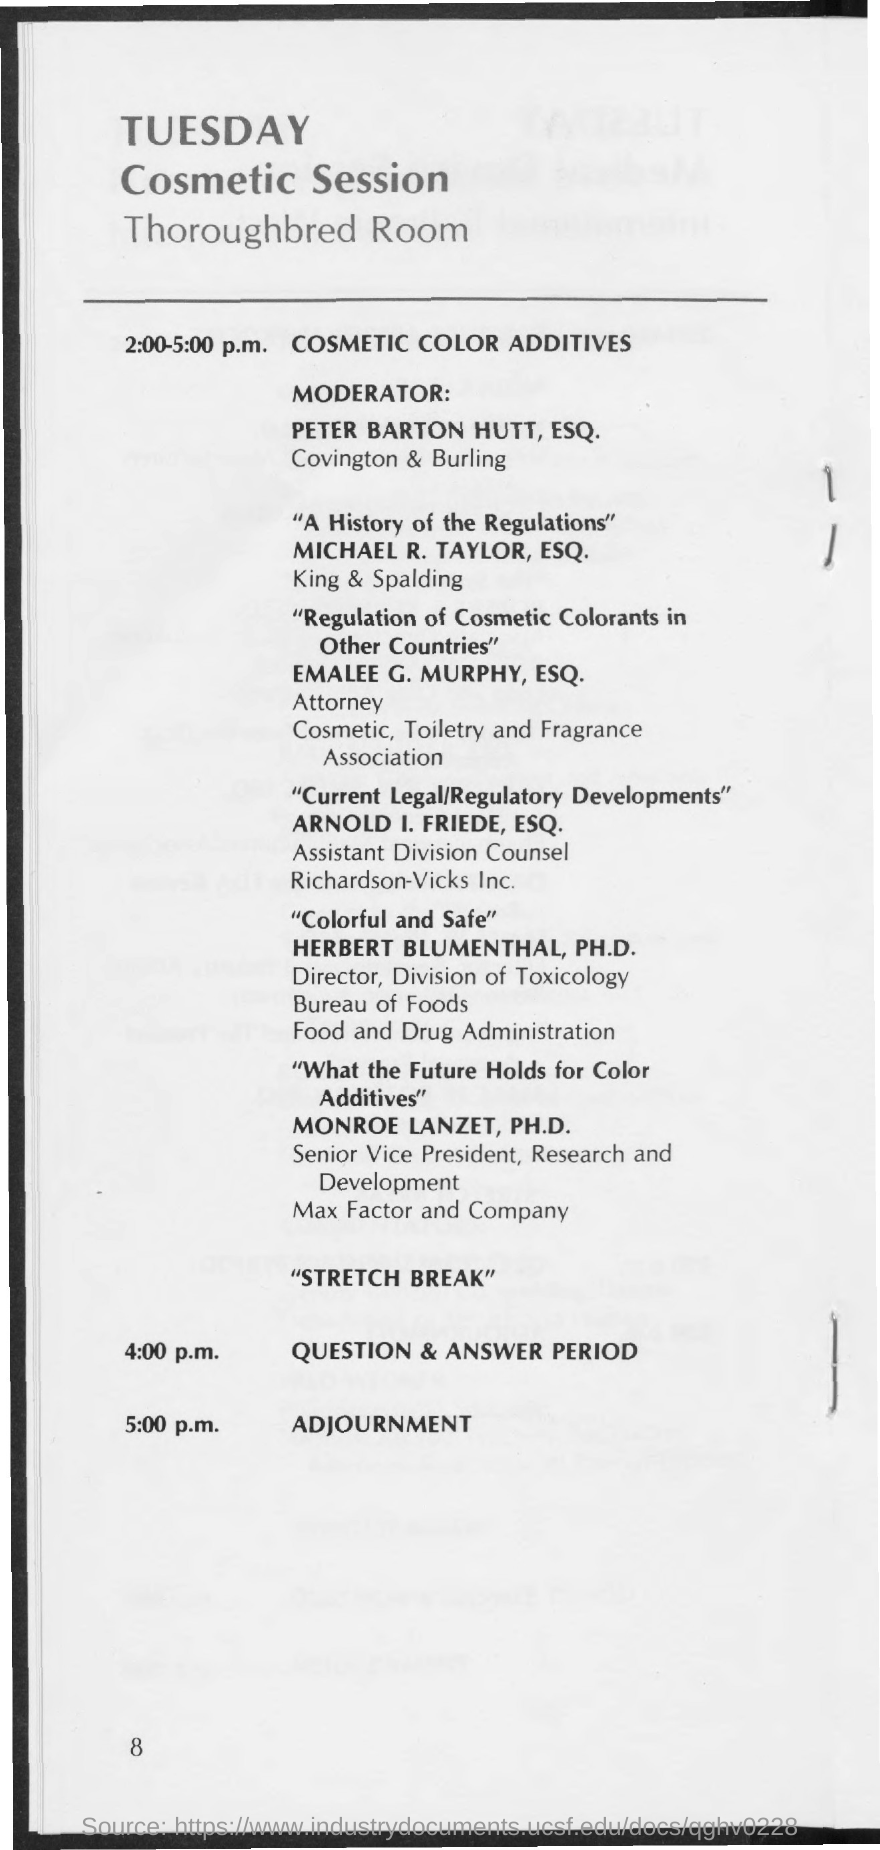Who is the moderator of the Cosmetic Session?
Keep it short and to the point. Peter Barton Hutt, ESQ. Which room is the Cosmetic Session scheduled ?
Keep it short and to the point. Thoroughbred Room. Which day of the week is the Cosmetic Session scheduled?
Provide a succinct answer. Tuesday. 